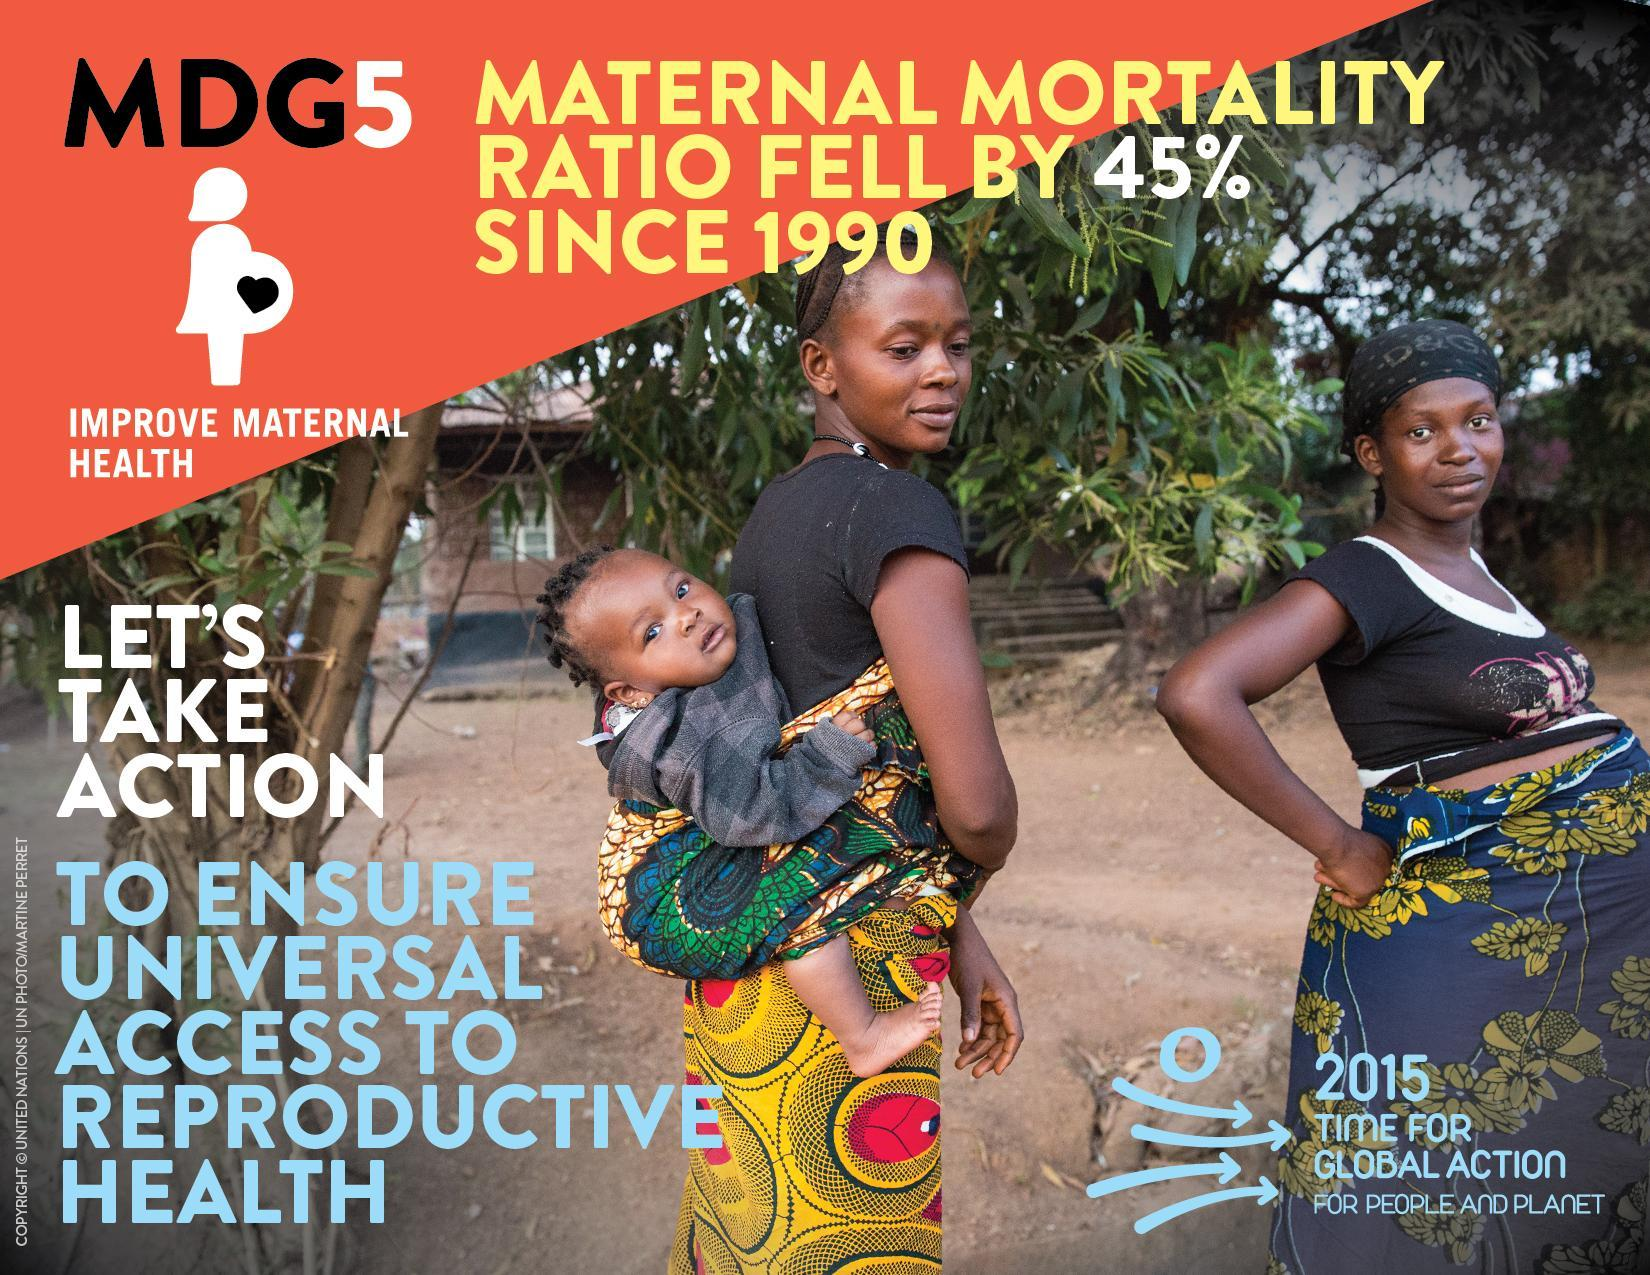How many children are shown in this image?
Answer the question with a short phrase. 1 How many women are shown in this image? 2 